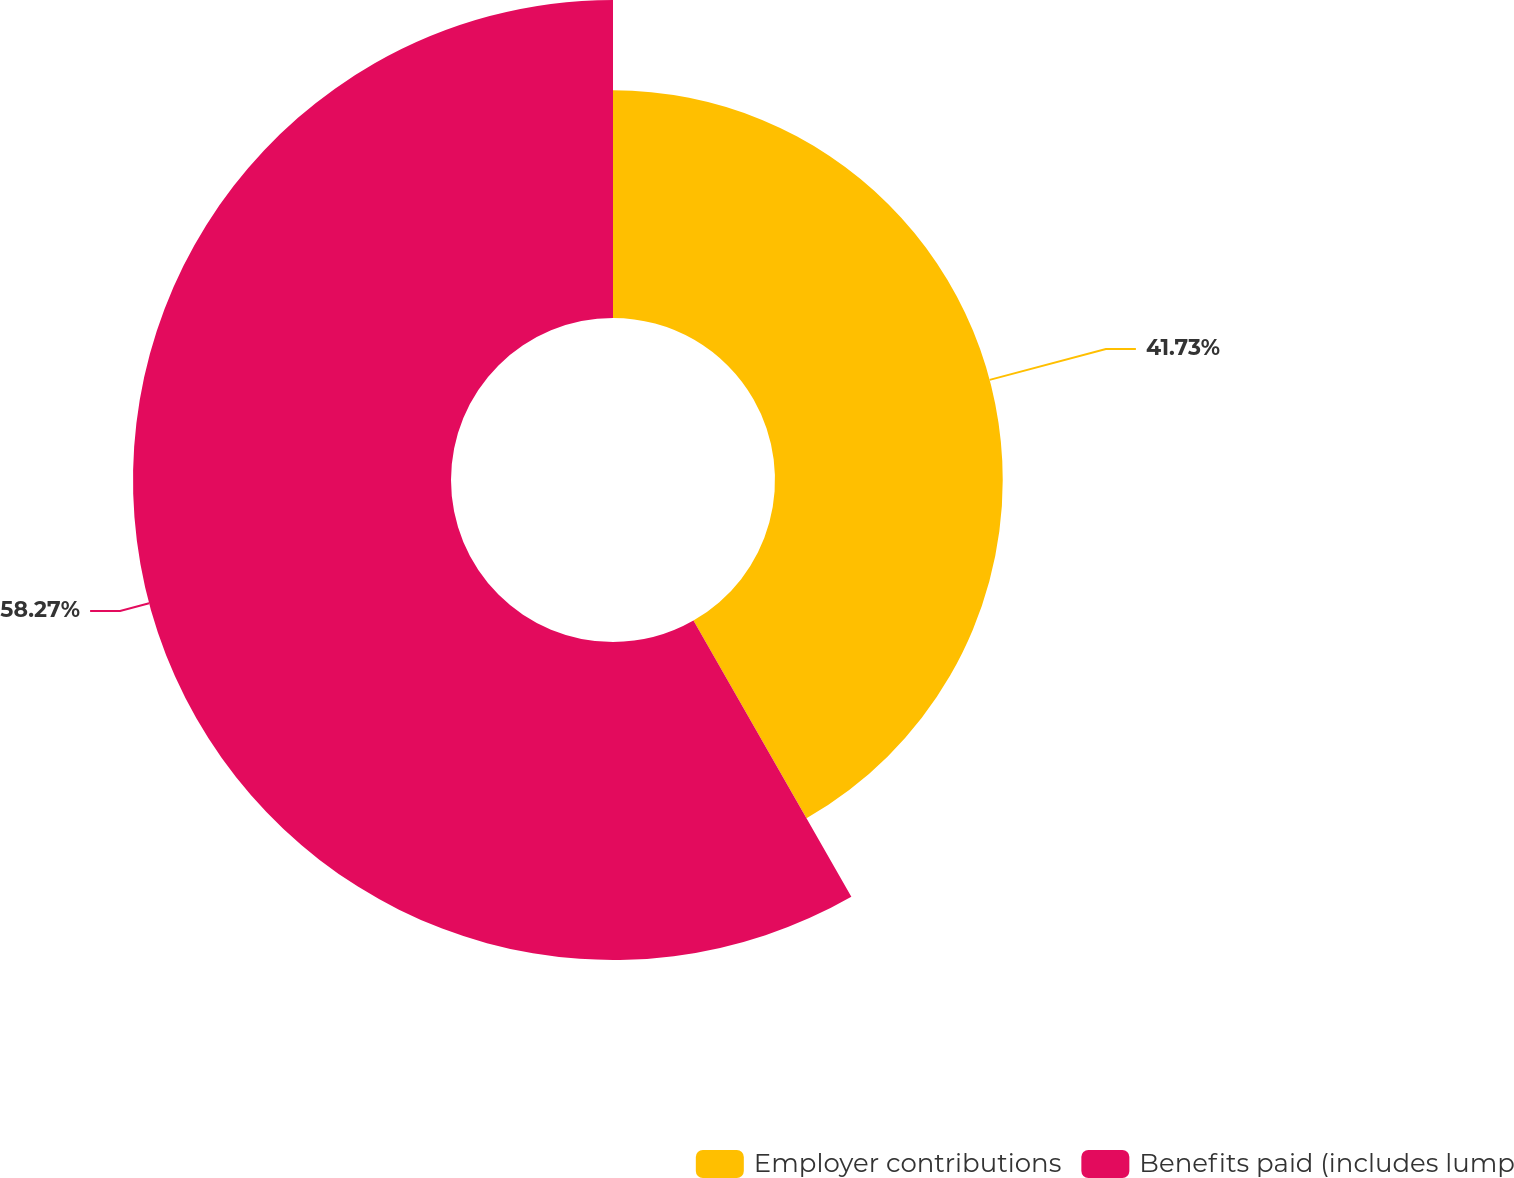<chart> <loc_0><loc_0><loc_500><loc_500><pie_chart><fcel>Employer contributions<fcel>Benefits paid (includes lump<nl><fcel>41.73%<fcel>58.27%<nl></chart> 